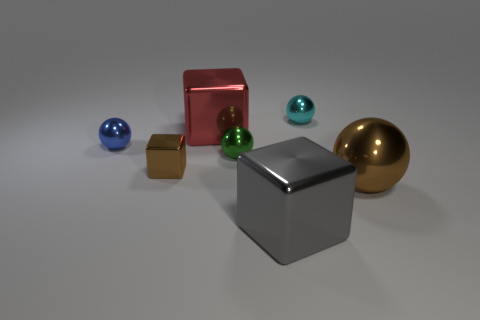Is the large metallic ball the same color as the small metallic block?
Your response must be concise. Yes. Is there any other thing that has the same color as the big metallic sphere?
Make the answer very short. Yes. There is a tiny ball that is to the right of the big shiny cube in front of the green object; is there a brown ball behind it?
Your answer should be compact. No. Are there any small metallic objects behind the small cyan object?
Ensure brevity in your answer.  No. There is a large gray metal thing; does it have the same shape as the tiny shiny thing that is behind the small blue sphere?
Offer a very short reply. No. What number of other things are there of the same material as the brown ball
Your answer should be very brief. 6. There is a small sphere that is right of the large block in front of the metallic ball in front of the small brown metallic cube; what color is it?
Offer a very short reply. Cyan. What shape is the blue metal thing left of the brown cube that is behind the large gray metal object?
Your answer should be very brief. Sphere. Is the number of large gray metallic cubes left of the large brown metal sphere greater than the number of big red cylinders?
Keep it short and to the point. Yes. Do the big shiny object on the left side of the gray metallic cube and the small blue thing have the same shape?
Your answer should be very brief. No. 